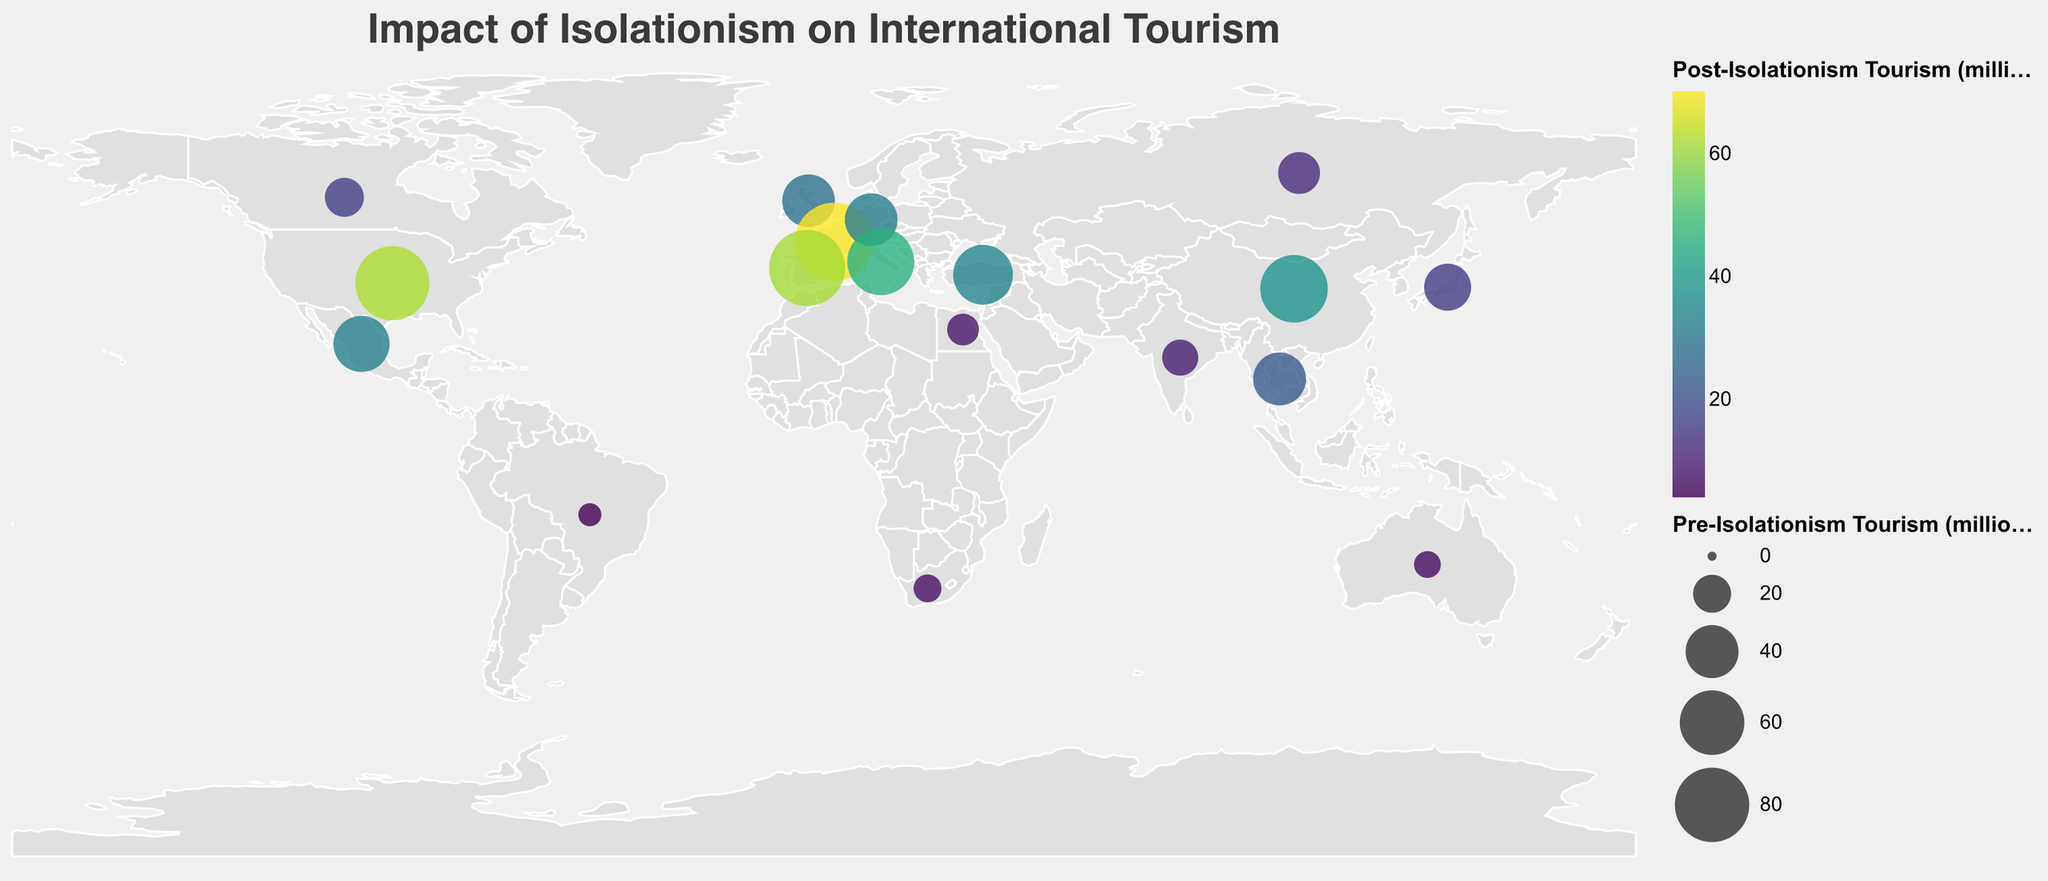Which country had the highest pre-isolationism tourism? The figure shows country sizes based on pre-isolationism tourism levels, and the largest circle indicates the highest value. The largest circle is over France.
Answer: France Which country experienced the largest decrease in tourism? By observing the size of circles before and after the isolationist measures and the color coding, Russia has the most noticeable shrinkage in the circle size and the darkest color, indicating the largest drop.
Answer: Russia Which two countries had similar pre-isolationism tourism levels but different post-isolationism levels? By comparing circle sizes and colors, Spain and the United States had similar pre-isolationism levels, but Spain's color is darker than the United States, indicating a steeper drop for Spain.
Answer: Spain and United States What is the average pre-isolationism tourism of all countries shown? Summing all pre-isolationism values given in the data: 79.3 + 31.2 + 39.4 + 89.4 + 39.6 + 64.5 + 83.7 + 9.3 + 21.1 + 45.0 + 6.6 + 24.6 + 65.7 + 17.9 + 10.2 + 39.8 + 13.6 + 51.2 = 731.1. There are 18 countries, so the average is 731.1 / 18.
Answer: 40.6 million Which country had the least change in tourism levels? By comparing the difference in circle sizes and colors, South Africa shows a relatively smaller difference pre-and-post with lighter color indicating a smaller decline.
Answer: South Africa In terms of percentage, which country saw the largest decline in tourism post-isolationism? The percentage drop is calculated as ((Pre - Post) / Pre) * 100. Russia: ((24.6 - 12.3) / 24.6) * 100 = 50%; Japan: ((31.2 - 15.6) / 31.2) * 100 = 50%; carefully comparing the values, Japan and Russia both saw a 50% decline.
Answer: Japan and Russia Which region had the most tourist-attracting countries pre-isolationism? Examining the geographic plot, Europe (France, United Kingdom, Germany, Italy, and Spain) shows multiple countries with large circles indicating high pre-isolationism tourism.
Answer: Europe How did China's tourism change compare to India's tourism change? Pre-isolationism China had 65.7 million and post 38.2 million, a difference of 27.5 million. India had 17.9 million pre and 9.4 million post, a difference of 8.5 million. China's absolute change is greater than India's.
Answer: China's decline was greater What can be inferred about the impact of isolationist measures on tourism in the Americas versus Asia? Identifying countries in the Americas (United States, Mexico, Brazil, Canada) and comparing with Asian countries (Japan, China, India, Thailand) in terms of circle size and color, all countries show declines, but drops appear more pronounced in Asia (darker colors, and significant circle size reduction).
Answer: Asia experienced a more significant decline 